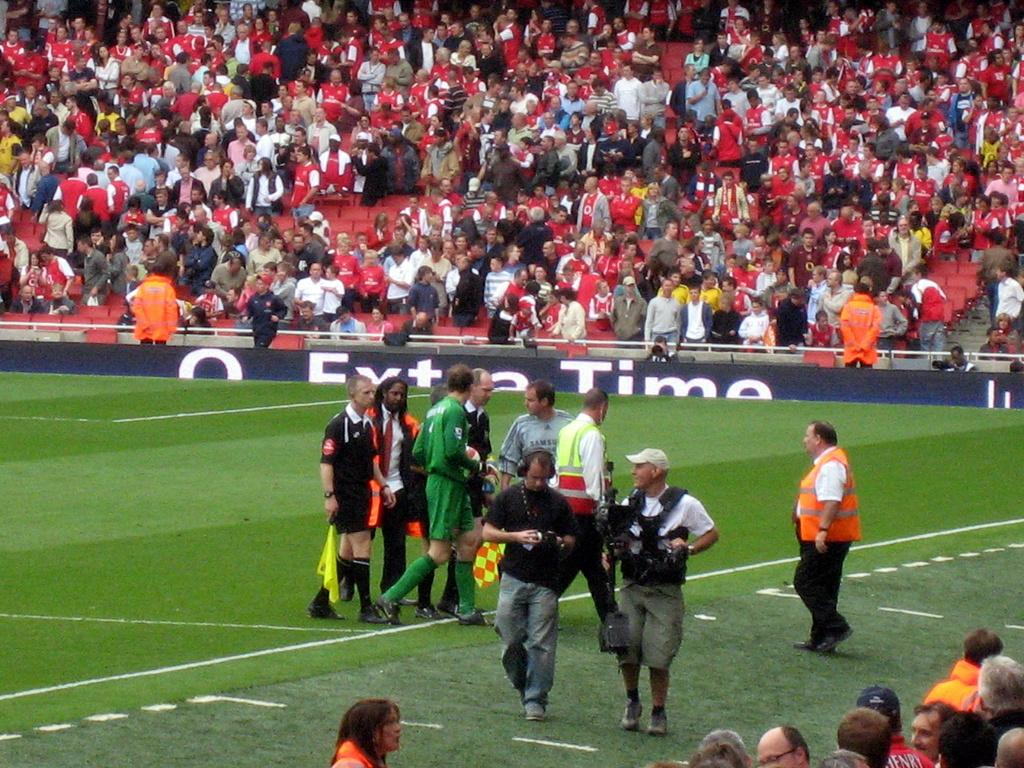<image>
Offer a succinct explanation of the picture presented. a soccer field with a sideline banner that says 'extra time' on it 